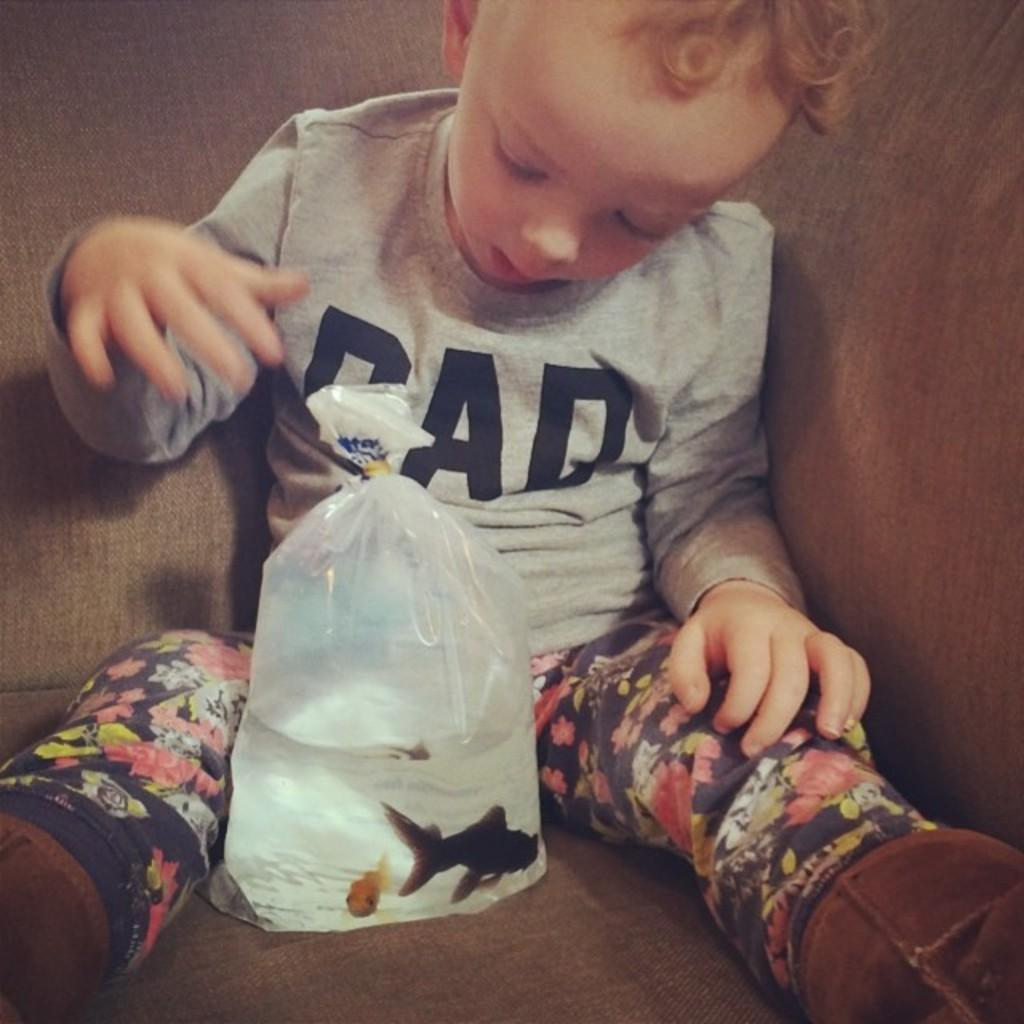Who is in the picture? There is a boy in the picture. What is the boy doing in the picture? The boy is seated. What is in front of the boy? There are fishes in front of the boy. How are the fishes contained in the image? The fishes are in a plastic cover. What is inside the plastic cover with the fishes? There is water in the plastic cover. How many coils are present in the image? There is no mention of coils in the image, so it is not possible to determine the amount. 